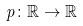<formula> <loc_0><loc_0><loc_500><loc_500>p \colon \mathbb { R } \rightarrow \mathbb { R }</formula> 